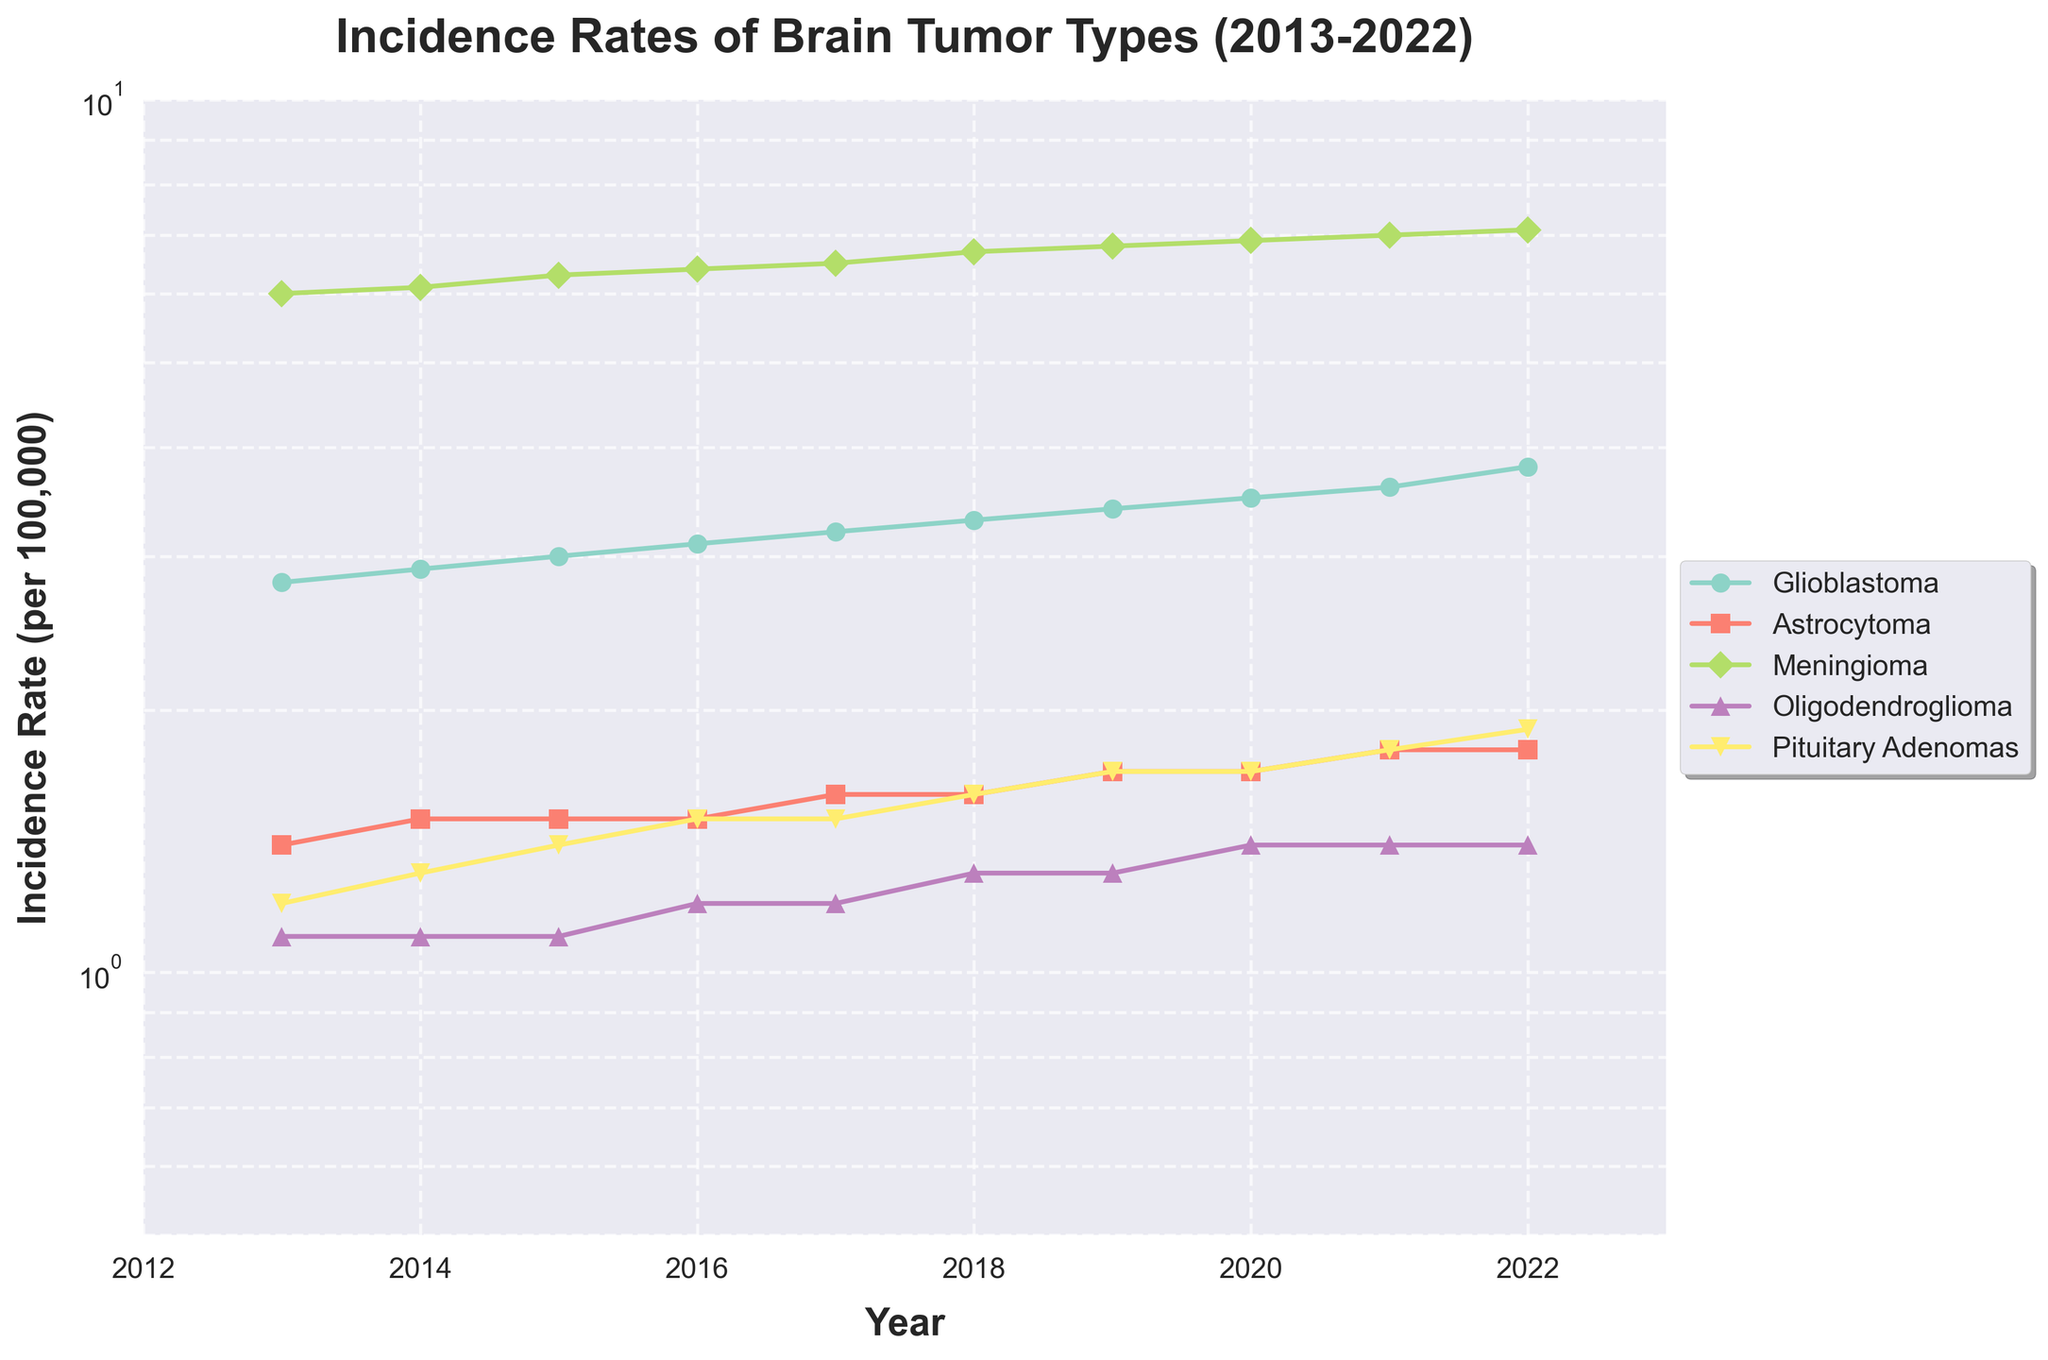What is the incidence rate of Meningioma in 2019? Locate the data point for Meningioma in the year 2019 on the plot. The incidence rate is 6.8.
Answer: 6.8 How has the incidence rate of Glioblastoma changed from 2013 to 2022? Compare the incidence rates of Glioblastoma from 2013 and 2022 by looking at the respective points on the graph. The incidence rate increased from 2.8 to 3.8.
Answer: Increased from 2.8 to 3.8 Which tumor type had the largest increase in incidence rate from 2013 to 2022? Evaluate the difference in incidence rates for each tumor type from 2013 to 2022. Glioblastoma increased by 1.0, Astrocytoma by 0.4, Meningioma by 1.1, Oligodendroglioma by 0.3, and Pituitary Adenomas by 0.7. The largest increase is for Meningioma.
Answer: Meningioma In which year did Astrocytoma first reach an incidence rate of 1.8 per 100,000? Find the first year on the plot when Astrocytoma reaches an incidence rate of 1.8. The year is 2021.
Answer: 2021 Compare the incidence rates of Pituitary Adenomas and Oligodendroglioma in 2016. Which is higher? Identify the incidence rates of both Pituitary Adenomas (1.5) and Oligodendroglioma (1.2) in 2016 from the plot. Pituitary Adenomas has a higher incidence rate.
Answer: Pituitary Adenomas What is the title of the figure? The title is typically at the top of the plot. Here it is "Incidence Rates of Brain Tumor Types (2013-2022)".
Answer: Incidence Rates of Brain Tumor Types (2013-2022) What is the trend of Glioblastoma's incidence rate over the given period? Observe the line representing Glioblastoma from 2013 to 2022. The line consistently increases, indicating an upward trend.
Answer: Upward trend On a log scale, which tumor type remains most stable over the decade? By checking the lines' slopes on the log scale, Astrocytoma shows the least change over the years, indicating it remains most stable.
Answer: Astrocytoma 